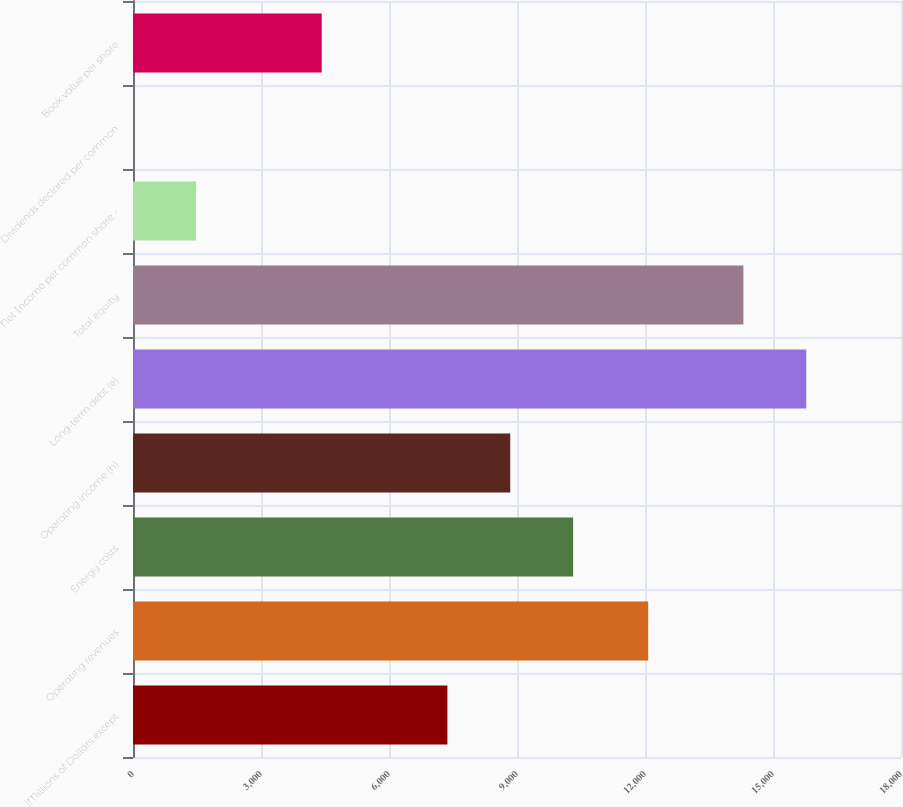<chart> <loc_0><loc_0><loc_500><loc_500><bar_chart><fcel>(Millions of Dollars except<fcel>Operating revenues<fcel>Energy costs<fcel>Operating income (h)<fcel>Long-term debt (e)<fcel>Total equity<fcel>Net Income per common share -<fcel>Dividends declared per common<fcel>Book value per share<nl><fcel>7368.83<fcel>12075<fcel>10315.3<fcel>8842.06<fcel>15779.2<fcel>14306<fcel>1475.91<fcel>2.68<fcel>4422.37<nl></chart> 